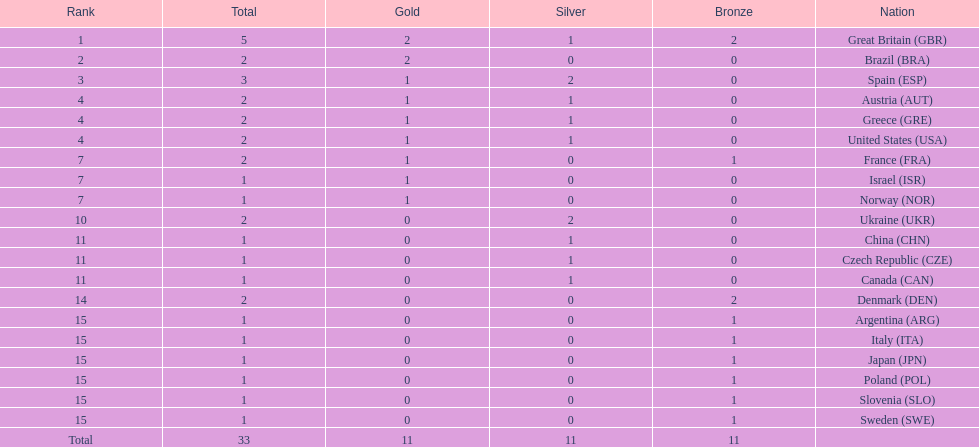How many medals did each country receive? 5, 2, 3, 2, 2, 2, 2, 1, 1, 2, 1, 1, 1, 2, 1, 1, 1, 1, 1, 1. Which country received 3 medals? Spain (ESP). 